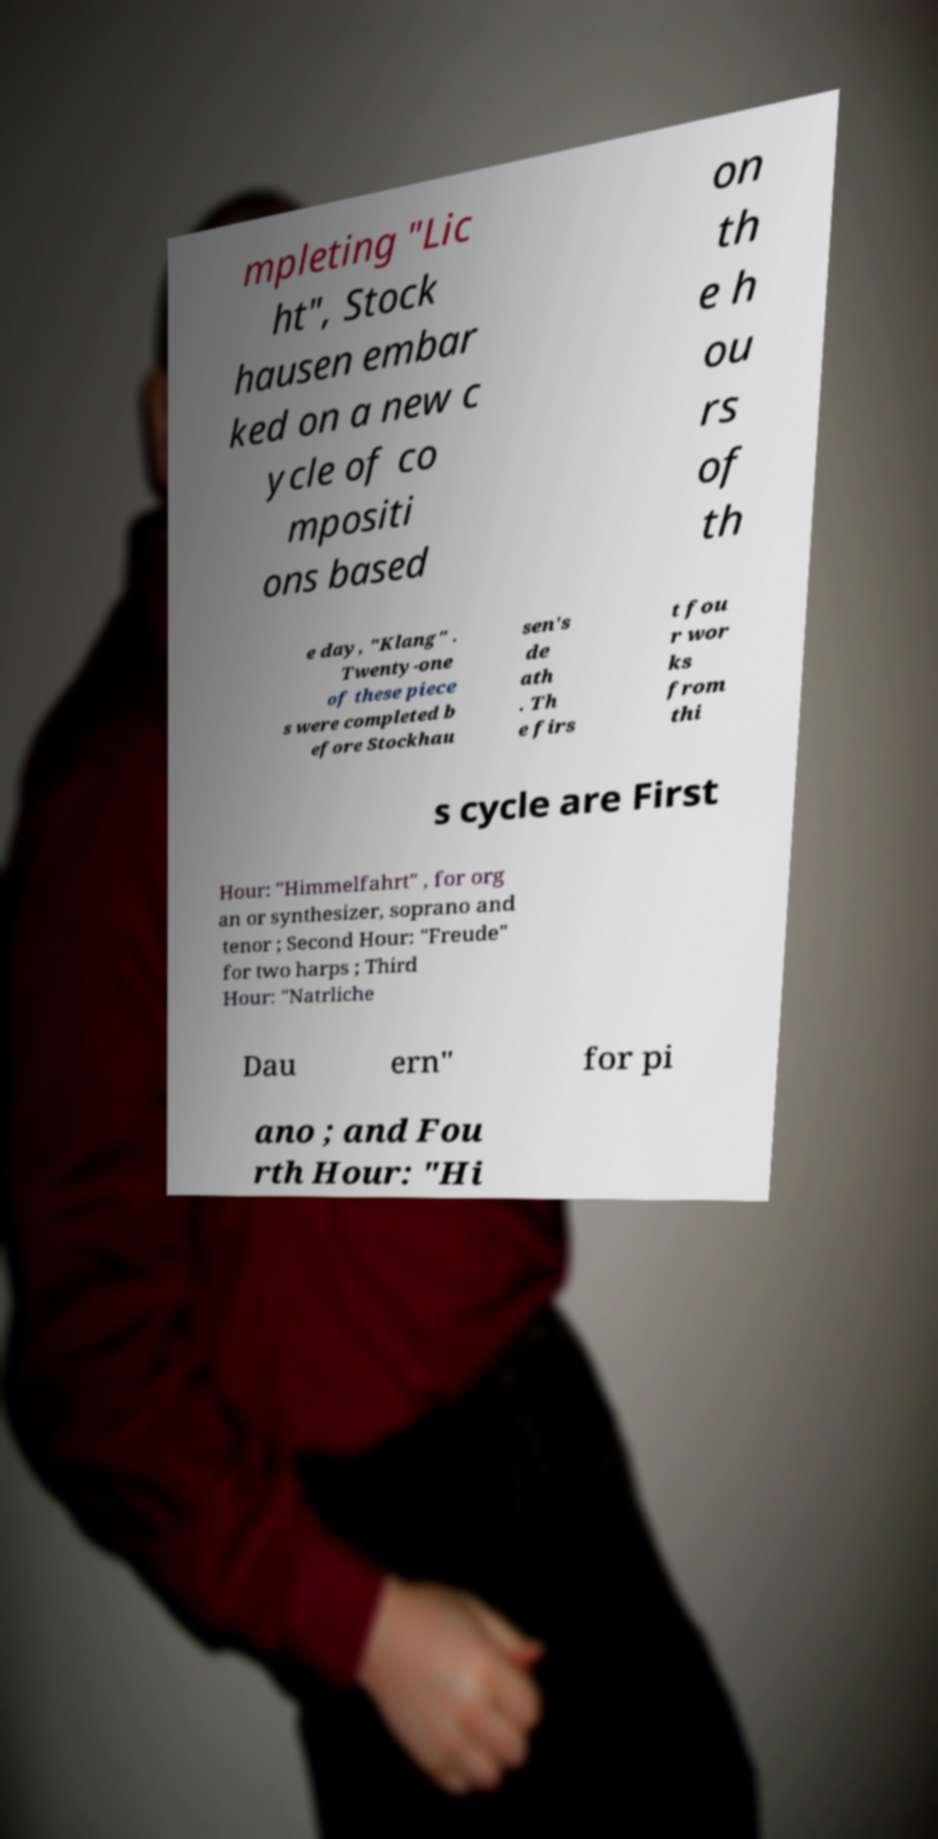What messages or text are displayed in this image? I need them in a readable, typed format. mpleting "Lic ht", Stock hausen embar ked on a new c ycle of co mpositi ons based on th e h ou rs of th e day, "Klang" . Twenty-one of these piece s were completed b efore Stockhau sen's de ath . Th e firs t fou r wor ks from thi s cycle are First Hour: "Himmelfahrt" , for org an or synthesizer, soprano and tenor ; Second Hour: "Freude" for two harps ; Third Hour: "Natrliche Dau ern" for pi ano ; and Fou rth Hour: "Hi 